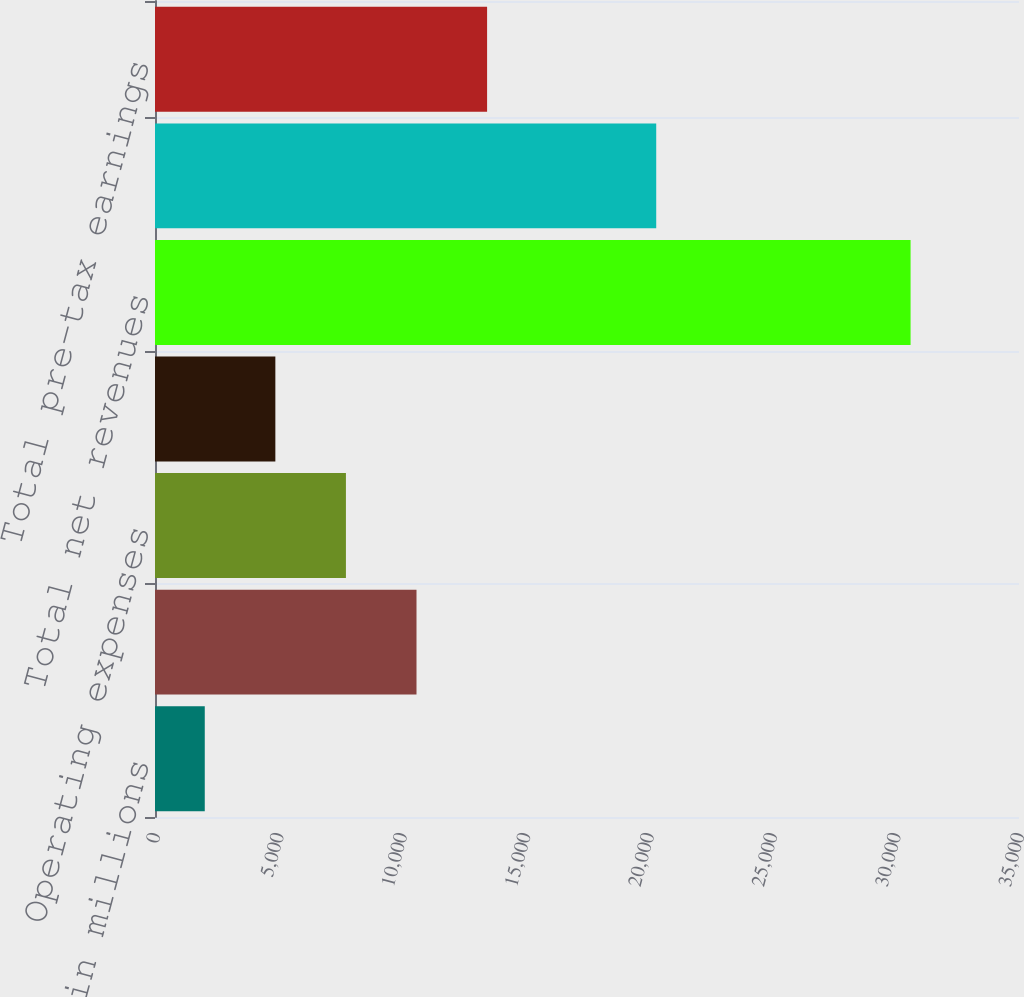<chart> <loc_0><loc_0><loc_500><loc_500><bar_chart><fcel>in millions<fcel>Net revenues<fcel>Operating expenses<fcel>Pre-tax earnings<fcel>Total net revenues<fcel>Total operating expenses<fcel>Total pre-tax earnings<nl><fcel>2016<fcel>10593.6<fcel>7734.4<fcel>4875.2<fcel>30608<fcel>20304<fcel>13452.8<nl></chart> 